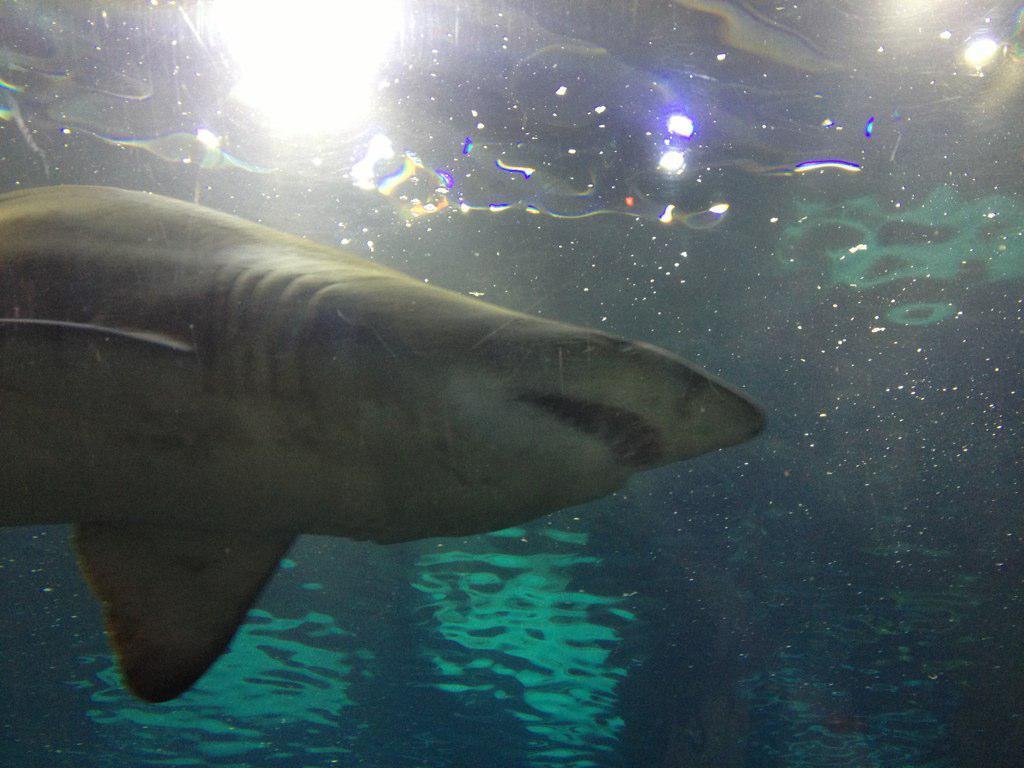Could you give a brief overview of what you see in this image? In this image we can see shark and lights are present in water. 